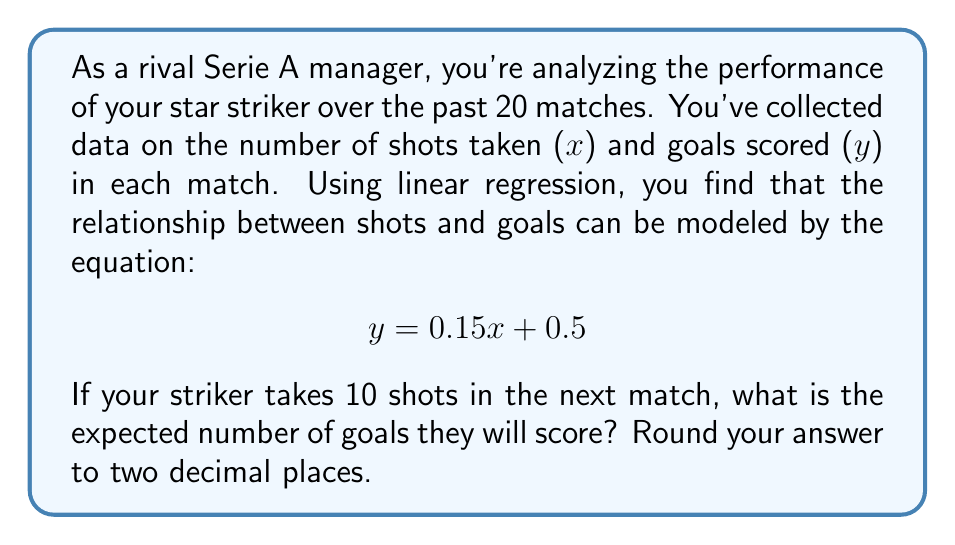Can you solve this math problem? To solve this problem, we'll use the linear regression equation provided and plug in the given value for x (number of shots).

1. The linear regression equation is:
   $$ y = 0.15x + 0.5 $$

   Where:
   - y is the predicted number of goals
   - x is the number of shots taken
   - 0.15 is the slope (indicating that for each additional shot, we expect 0.15 more goals on average)
   - 0.5 is the y-intercept (the expected number of goals when no shots are taken)

2. We're told that the striker will take 10 shots in the next match, so x = 10.

3. Let's substitute x = 10 into the equation:
   $$ y = 0.15(10) + 0.5 $$

4. Simplify:
   $$ y = 1.5 + 0.5 $$
   $$ y = 2 $$

5. The result is exactly 2, so no rounding is necessary.

This means that based on the linear regression model, if the striker takes 10 shots in the next match, we would expect them to score 2 goals on average.
Answer: 2.00 goals 